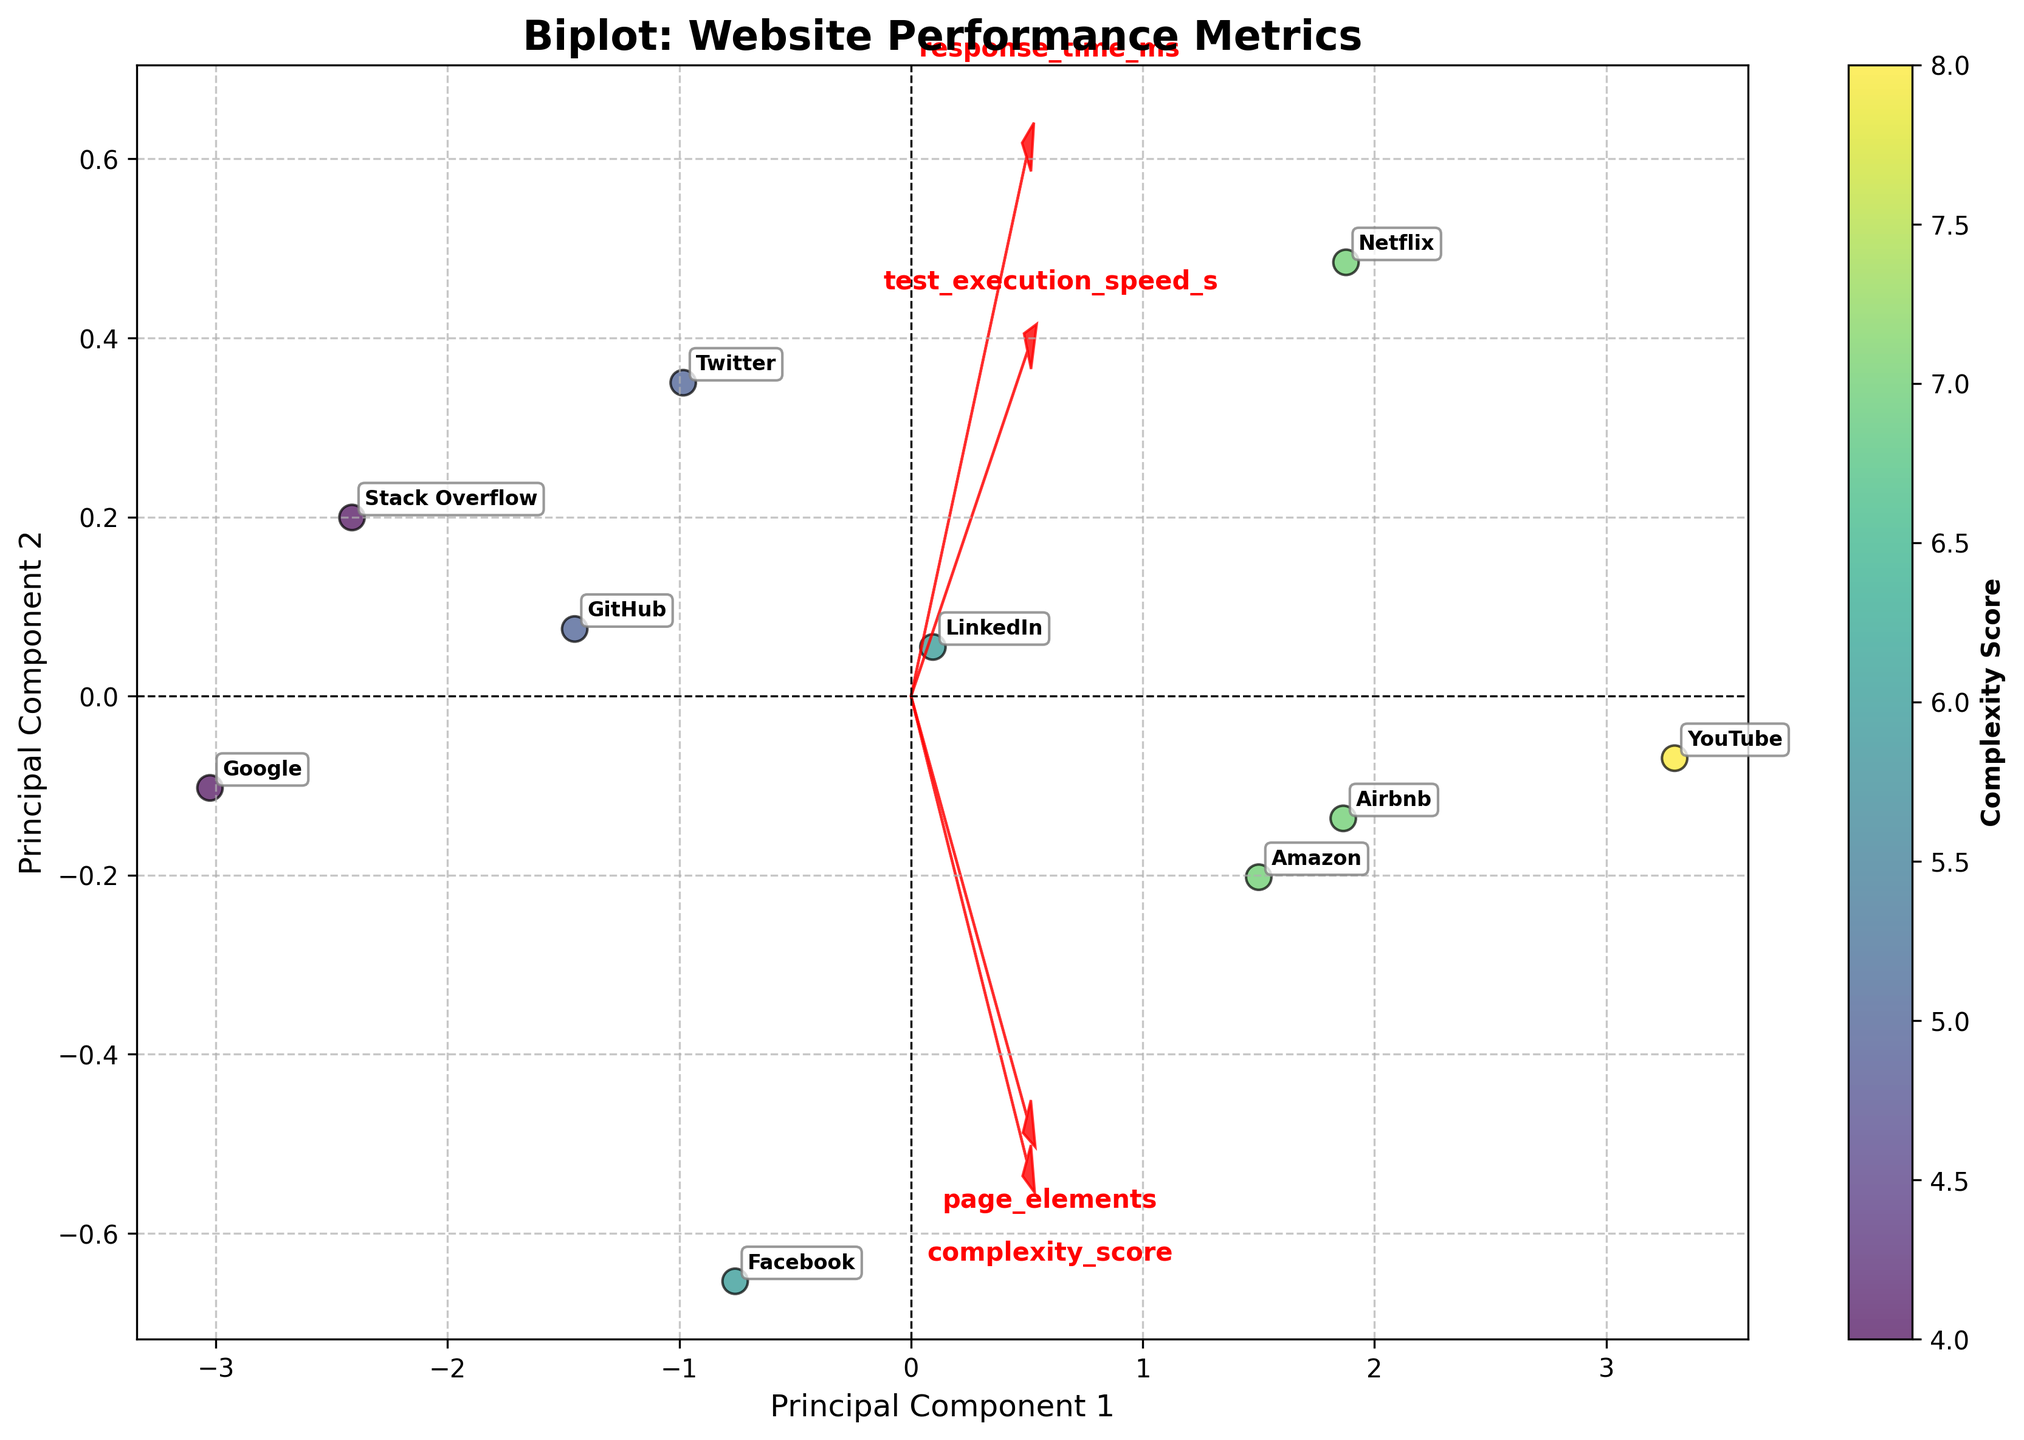What is the title of the plot? The title is positioned at the top of the plot and is displayed prominently. It provides the overall summary of the visual representation.
Answer: Biplot: Website Performance Metrics How many websites' data points are presented in the plot? Each website's data point is annotated with its name in the plot. By counting these annotations, you can determine the number of data points.
Answer: 10 Which website has the highest complexity score? The color of the data points represents the complexity score, with the color bar indicating the corresponding colors. The darkest color signifies the highest complexity score.
Answer: YouTube Which two features have arrows nearly parallel to each other? The arrows representing features indicate their directions in the principal component space. Two arrows that are almost parallel suggest a high correlation between the corresponding features.
Answer: response_time_ms and page_elements Which website is located closest to the origin (0, 0) of the plot? The origin of the plot is the point where the x and y axes intersect. The website closest to this point has coordinates nearest to (0, 0).
Answer: Facebook What are the labels of the principal components on the axes? The axes are labeled to indicate the principal components derived from PCA, which summarize the data variance in two dimensions. These labels are usually displayed along the axes.
Answer: Principal Component 1 and Principal Component 2 Which website had the fastest test execution speed? By examining the scatter plot, the website with the lowest position along the 'test_execution_speed_s' feature vector has the fastest execution speed.
Answer: Google How does the arrow length of response_time_ms compare to test_execution_speed_s? The length of the arrows in a biplot represents the contribution of each feature to the principal components. A longer arrow indicates a higher contribution. Compare the lengths of these two feature vectors.
Answer: The arrow of response_time_ms is longer Which website shows the lowest combined complexity score and page_elements? By analyzing the data points and their color intensities, find the website positioned farthest along the direction of lowest complexity score and page_elements.
Answer: Stack Overflow What is the relationship between response_time_ms and page_elements? The direction and proximity of the feature arrows to each other indicate their correlation. Parallel arrows imply a positive correlation, while perpendicular ones imply no correlation.
Answer: They are positively correlated 